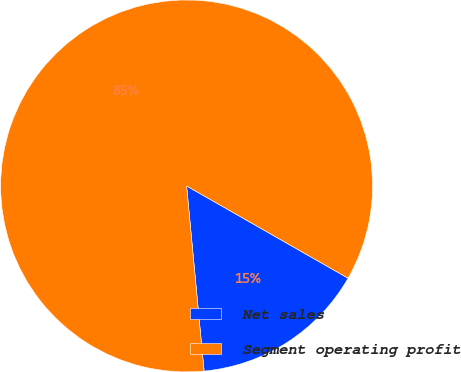<chart> <loc_0><loc_0><loc_500><loc_500><pie_chart><fcel>Net sales<fcel>Segment operating profit<nl><fcel>15.24%<fcel>84.76%<nl></chart> 